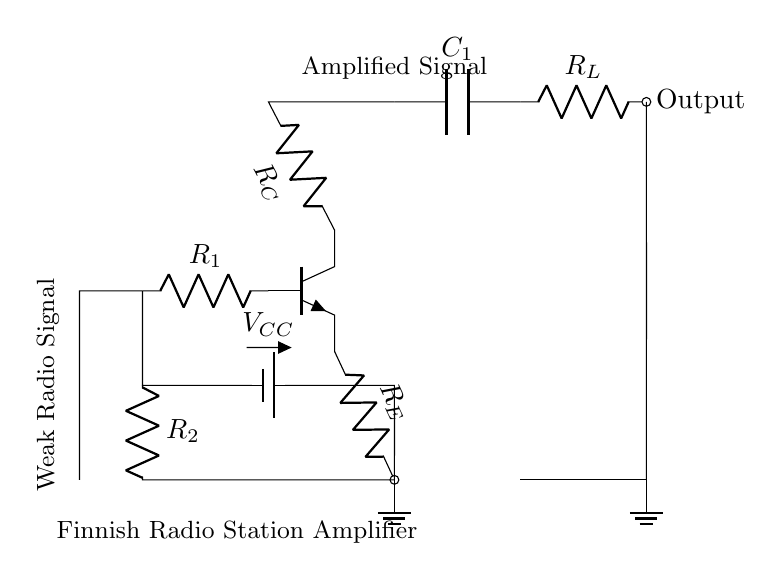What type of transistor is used in this circuit? The circuit uses an NPN transistor, as indicated by the notation in the diagram.
Answer: NPN What component is used to couple the output? A capacitor is used to couple the output signal, denoted as C1 in the circuit.
Answer: Capacitor What is the function of resistor R1? Resistor R1 is used to limit the current from the weak radio signal input to the base of the transistor, making it essential for signal amplification.
Answer: Limit current What is the purpose of the voltage supply VCC? The voltage supply VCC provides the necessary power for the circuit to operate, enabling the transistors to amplify the incoming weak radio signals.
Answer: Power supply What is the overall purpose of this circuit? The circuit is designed to amplify weak radio signals from distant Finnish stations, making them clearer for reception.
Answer: Amplify radio signals What does the output represent in this circuit? The output represents the amplified signal, which is indicated at the output terminal after the capacitor and load resistor.
Answer: Amplified signal 